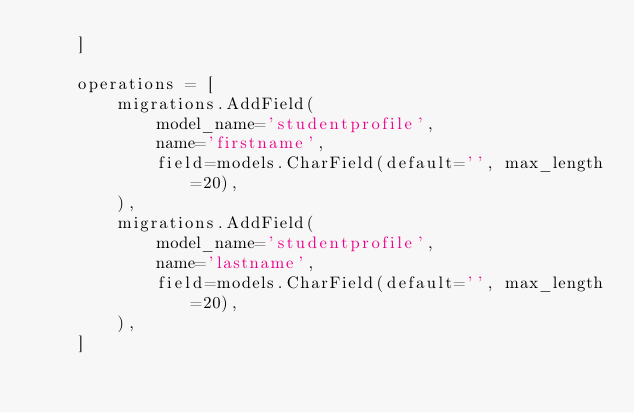<code> <loc_0><loc_0><loc_500><loc_500><_Python_>    ]

    operations = [
        migrations.AddField(
            model_name='studentprofile',
            name='firstname',
            field=models.CharField(default='', max_length=20),
        ),
        migrations.AddField(
            model_name='studentprofile',
            name='lastname',
            field=models.CharField(default='', max_length=20),
        ),
    ]
</code> 